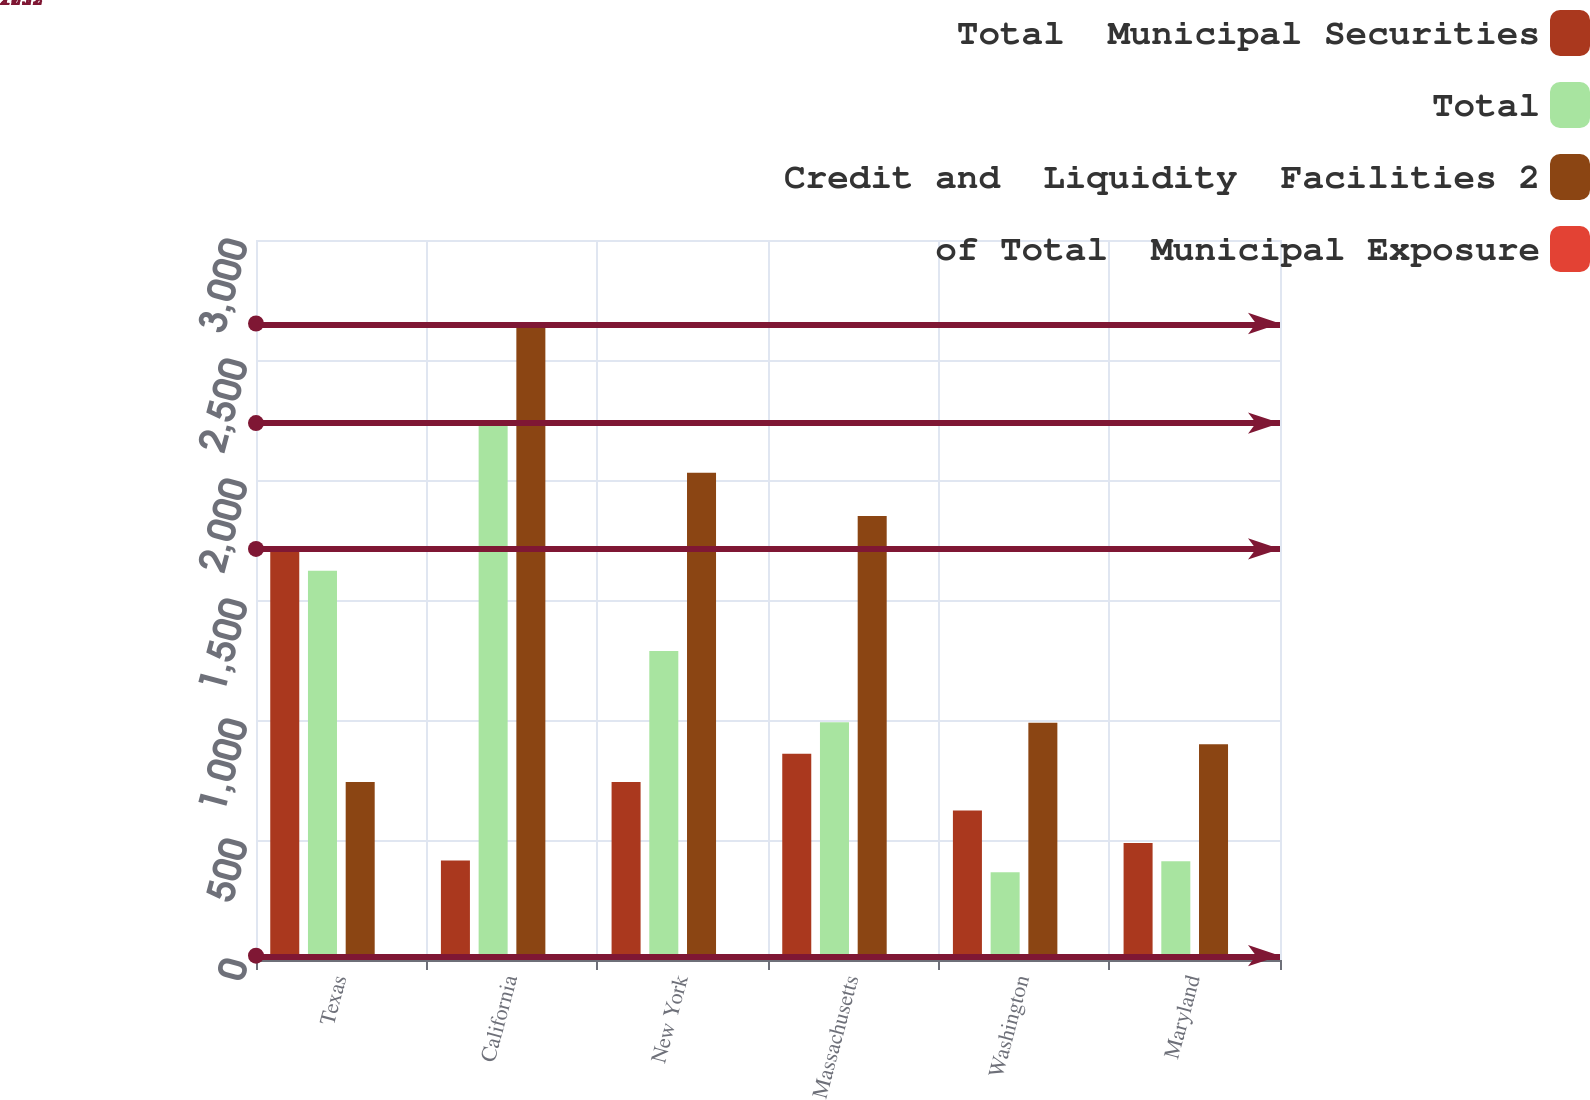Convert chart to OTSL. <chart><loc_0><loc_0><loc_500><loc_500><stacked_bar_chart><ecel><fcel>Texas<fcel>California<fcel>New York<fcel>Massachusetts<fcel>Washington<fcel>Maryland<nl><fcel>Total  Municipal Securities<fcel>1713<fcel>415<fcel>742<fcel>859<fcel>623<fcel>488<nl><fcel>Total<fcel>1622<fcel>2237<fcel>1288<fcel>991<fcel>366<fcel>411<nl><fcel>Credit and  Liquidity  Facilities 2<fcel>742<fcel>2652<fcel>2030<fcel>1850<fcel>989<fcel>899<nl><fcel>of Total  Municipal Exposure<fcel>18<fcel>14<fcel>11<fcel>10<fcel>5<fcel>5<nl></chart> 